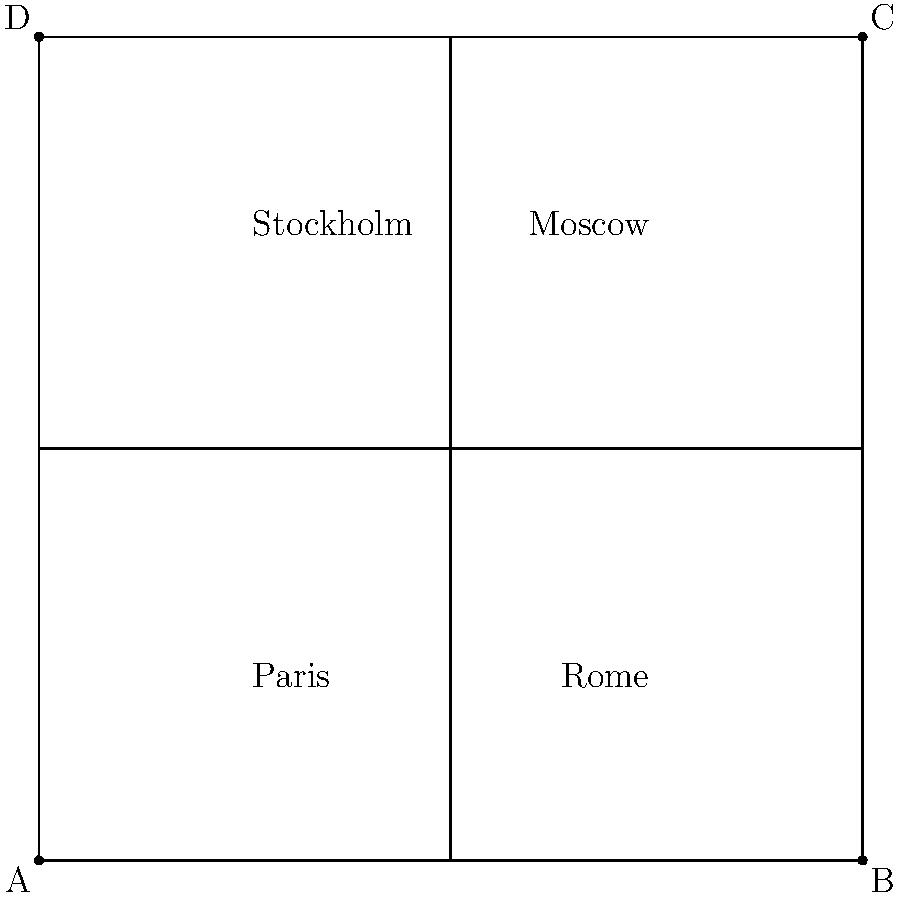If the map of Europe is folded along both diagonals, which two cultural landmarks would be directly aligned, potentially symbolizing a clash of traditional European values? To solve this problem, we need to visualize the folding process of the map along its diagonals:

1. The map is represented as a square, with four major European cities marked at different corners.
2. The diagonals of the square are AC (from top-right to bottom-left) and BD (from top-left to bottom-right).
3. When folded along diagonal AC:
   - Point A will align with point C
   - Paris (bottom-left) will align with Moscow (top-right)
4. When folded along diagonal BD:
   - Point B will align with point D
   - Rome (bottom-right) will align with Stockholm (top-left)
5. When both folds are made simultaneously, all four corners will align at the center.

The question asks which two landmarks would be directly aligned, potentially symbolizing a clash of traditional European values. Given the persona of a traditionalist author challenging diversity, the most fitting answer would be the alignment of Rome (representing traditional Western European values) and Moscow (representing traditional Eastern European values).
Answer: Rome and Moscow 